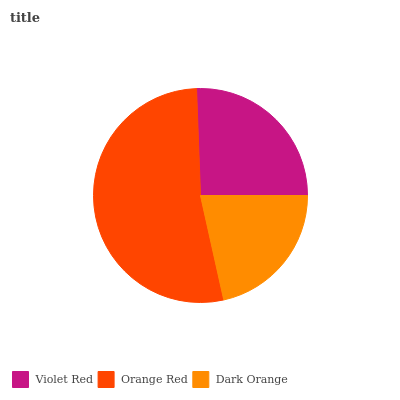Is Dark Orange the minimum?
Answer yes or no. Yes. Is Orange Red the maximum?
Answer yes or no. Yes. Is Orange Red the minimum?
Answer yes or no. No. Is Dark Orange the maximum?
Answer yes or no. No. Is Orange Red greater than Dark Orange?
Answer yes or no. Yes. Is Dark Orange less than Orange Red?
Answer yes or no. Yes. Is Dark Orange greater than Orange Red?
Answer yes or no. No. Is Orange Red less than Dark Orange?
Answer yes or no. No. Is Violet Red the high median?
Answer yes or no. Yes. Is Violet Red the low median?
Answer yes or no. Yes. Is Dark Orange the high median?
Answer yes or no. No. Is Dark Orange the low median?
Answer yes or no. No. 